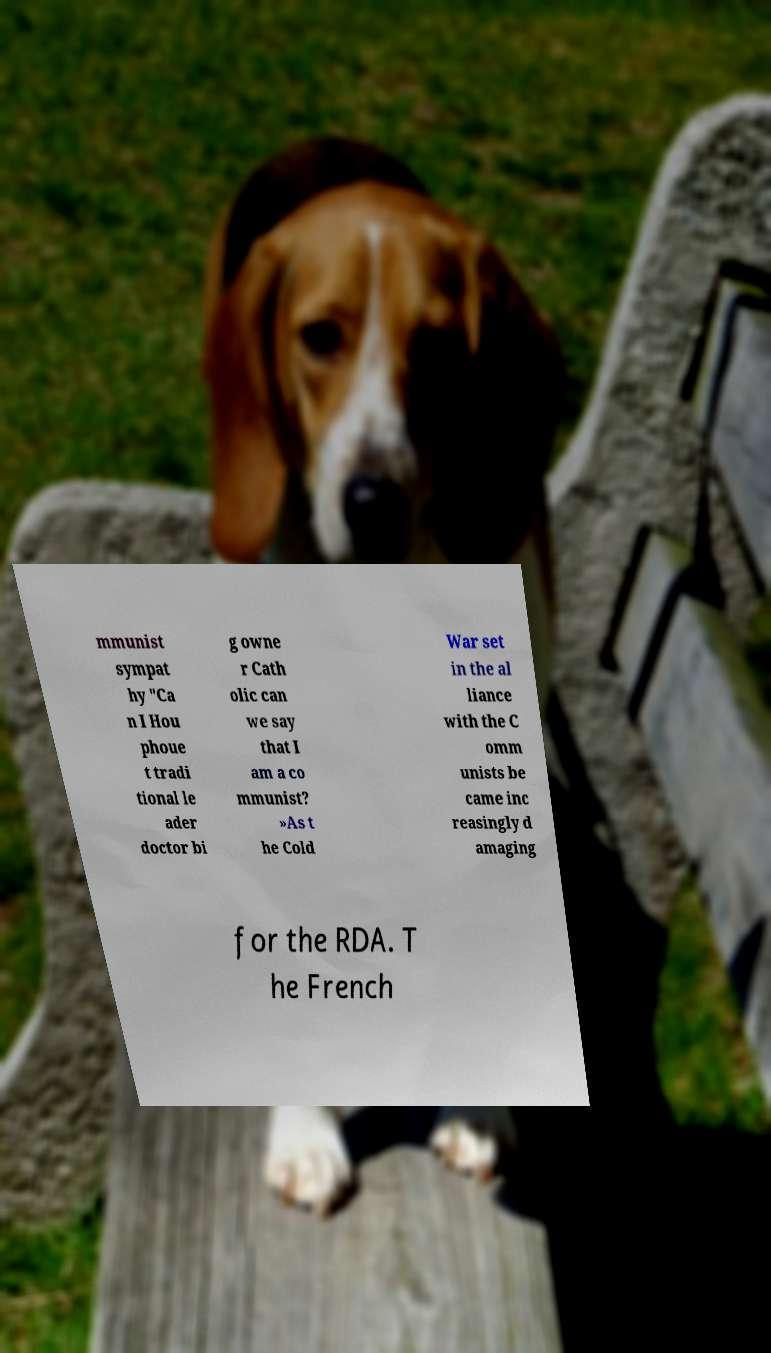What messages or text are displayed in this image? I need them in a readable, typed format. mmunist sympat hy "Ca n I Hou phoue t tradi tional le ader doctor bi g owne r Cath olic can we say that I am a co mmunist? »As t he Cold War set in the al liance with the C omm unists be came inc reasingly d amaging for the RDA. T he French 